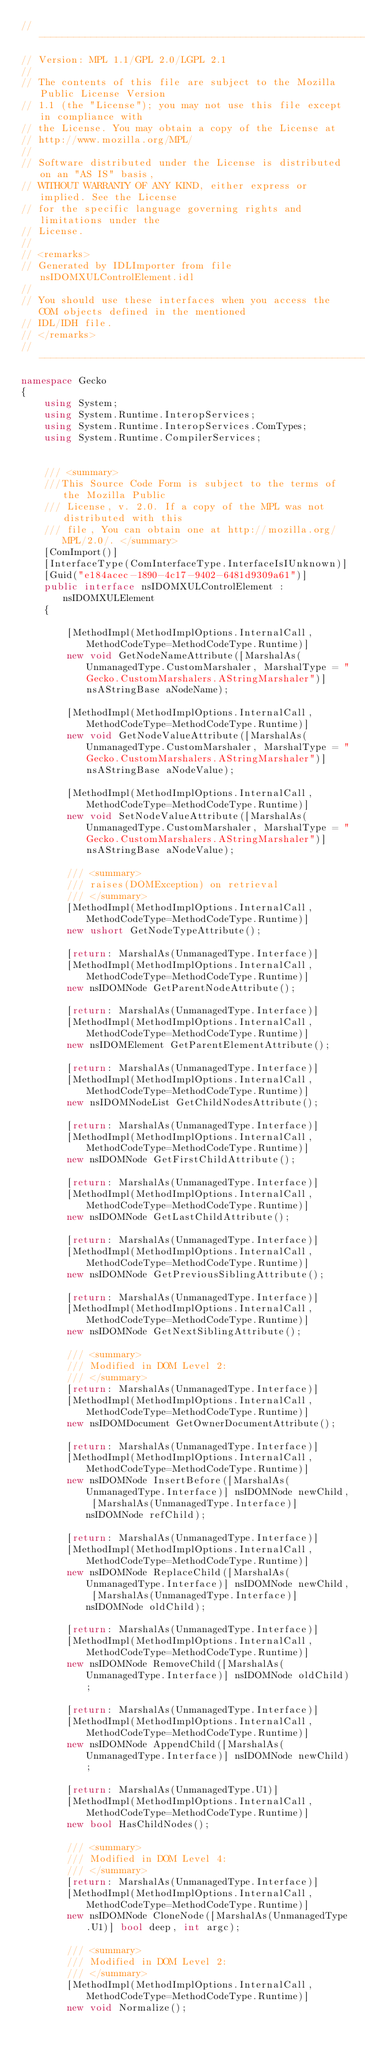Convert code to text. <code><loc_0><loc_0><loc_500><loc_500><_C#_>// --------------------------------------------------------------------------------------------
// Version: MPL 1.1/GPL 2.0/LGPL 2.1
// 
// The contents of this file are subject to the Mozilla Public License Version
// 1.1 (the "License"); you may not use this file except in compliance with
// the License. You may obtain a copy of the License at
// http://www.mozilla.org/MPL/
// 
// Software distributed under the License is distributed on an "AS IS" basis,
// WITHOUT WARRANTY OF ANY KIND, either express or implied. See the License
// for the specific language governing rights and limitations under the
// License.
// 
// <remarks>
// Generated by IDLImporter from file nsIDOMXULControlElement.idl
// 
// You should use these interfaces when you access the COM objects defined in the mentioned
// IDL/IDH file.
// </remarks>
// --------------------------------------------------------------------------------------------
namespace Gecko
{
	using System;
	using System.Runtime.InteropServices;
	using System.Runtime.InteropServices.ComTypes;
	using System.Runtime.CompilerServices;
	
	
	/// <summary>
    ///This Source Code Form is subject to the terms of the Mozilla Public
    /// License, v. 2.0. If a copy of the MPL was not distributed with this
    /// file, You can obtain one at http://mozilla.org/MPL/2.0/. </summary>
	[ComImport()]
	[InterfaceType(ComInterfaceType.InterfaceIsIUnknown)]
	[Guid("e184acec-1890-4c17-9402-6481d9309a61")]
	public interface nsIDOMXULControlElement : nsIDOMXULElement
	{
		
		[MethodImpl(MethodImplOptions.InternalCall, MethodCodeType=MethodCodeType.Runtime)]
		new void GetNodeNameAttribute([MarshalAs(UnmanagedType.CustomMarshaler, MarshalType = "Gecko.CustomMarshalers.AStringMarshaler")] nsAStringBase aNodeName);
		
		[MethodImpl(MethodImplOptions.InternalCall, MethodCodeType=MethodCodeType.Runtime)]
		new void GetNodeValueAttribute([MarshalAs(UnmanagedType.CustomMarshaler, MarshalType = "Gecko.CustomMarshalers.AStringMarshaler")] nsAStringBase aNodeValue);
		
		[MethodImpl(MethodImplOptions.InternalCall, MethodCodeType=MethodCodeType.Runtime)]
		new void SetNodeValueAttribute([MarshalAs(UnmanagedType.CustomMarshaler, MarshalType = "Gecko.CustomMarshalers.AStringMarshaler")] nsAStringBase aNodeValue);
		
		/// <summary>
        /// raises(DOMException) on retrieval
        /// </summary>
		[MethodImpl(MethodImplOptions.InternalCall, MethodCodeType=MethodCodeType.Runtime)]
		new ushort GetNodeTypeAttribute();
		
		[return: MarshalAs(UnmanagedType.Interface)]
		[MethodImpl(MethodImplOptions.InternalCall, MethodCodeType=MethodCodeType.Runtime)]
		new nsIDOMNode GetParentNodeAttribute();
		
		[return: MarshalAs(UnmanagedType.Interface)]
		[MethodImpl(MethodImplOptions.InternalCall, MethodCodeType=MethodCodeType.Runtime)]
		new nsIDOMElement GetParentElementAttribute();
		
		[return: MarshalAs(UnmanagedType.Interface)]
		[MethodImpl(MethodImplOptions.InternalCall, MethodCodeType=MethodCodeType.Runtime)]
		new nsIDOMNodeList GetChildNodesAttribute();
		
		[return: MarshalAs(UnmanagedType.Interface)]
		[MethodImpl(MethodImplOptions.InternalCall, MethodCodeType=MethodCodeType.Runtime)]
		new nsIDOMNode GetFirstChildAttribute();
		
		[return: MarshalAs(UnmanagedType.Interface)]
		[MethodImpl(MethodImplOptions.InternalCall, MethodCodeType=MethodCodeType.Runtime)]
		new nsIDOMNode GetLastChildAttribute();
		
		[return: MarshalAs(UnmanagedType.Interface)]
		[MethodImpl(MethodImplOptions.InternalCall, MethodCodeType=MethodCodeType.Runtime)]
		new nsIDOMNode GetPreviousSiblingAttribute();
		
		[return: MarshalAs(UnmanagedType.Interface)]
		[MethodImpl(MethodImplOptions.InternalCall, MethodCodeType=MethodCodeType.Runtime)]
		new nsIDOMNode GetNextSiblingAttribute();
		
		/// <summary>
        /// Modified in DOM Level 2:
        /// </summary>
		[return: MarshalAs(UnmanagedType.Interface)]
		[MethodImpl(MethodImplOptions.InternalCall, MethodCodeType=MethodCodeType.Runtime)]
		new nsIDOMDocument GetOwnerDocumentAttribute();
		
		[return: MarshalAs(UnmanagedType.Interface)]
		[MethodImpl(MethodImplOptions.InternalCall, MethodCodeType=MethodCodeType.Runtime)]
		new nsIDOMNode InsertBefore([MarshalAs(UnmanagedType.Interface)] nsIDOMNode newChild, [MarshalAs(UnmanagedType.Interface)] nsIDOMNode refChild);
		
		[return: MarshalAs(UnmanagedType.Interface)]
		[MethodImpl(MethodImplOptions.InternalCall, MethodCodeType=MethodCodeType.Runtime)]
		new nsIDOMNode ReplaceChild([MarshalAs(UnmanagedType.Interface)] nsIDOMNode newChild, [MarshalAs(UnmanagedType.Interface)] nsIDOMNode oldChild);
		
		[return: MarshalAs(UnmanagedType.Interface)]
		[MethodImpl(MethodImplOptions.InternalCall, MethodCodeType=MethodCodeType.Runtime)]
		new nsIDOMNode RemoveChild([MarshalAs(UnmanagedType.Interface)] nsIDOMNode oldChild);
		
		[return: MarshalAs(UnmanagedType.Interface)]
		[MethodImpl(MethodImplOptions.InternalCall, MethodCodeType=MethodCodeType.Runtime)]
		new nsIDOMNode AppendChild([MarshalAs(UnmanagedType.Interface)] nsIDOMNode newChild);
		
		[return: MarshalAs(UnmanagedType.U1)]
		[MethodImpl(MethodImplOptions.InternalCall, MethodCodeType=MethodCodeType.Runtime)]
		new bool HasChildNodes();
		
		/// <summary>
        /// Modified in DOM Level 4:
        /// </summary>
		[return: MarshalAs(UnmanagedType.Interface)]
		[MethodImpl(MethodImplOptions.InternalCall, MethodCodeType=MethodCodeType.Runtime)]
		new nsIDOMNode CloneNode([MarshalAs(UnmanagedType.U1)] bool deep, int argc);
		
		/// <summary>
        /// Modified in DOM Level 2:
        /// </summary>
		[MethodImpl(MethodImplOptions.InternalCall, MethodCodeType=MethodCodeType.Runtime)]
		new void Normalize();</code> 